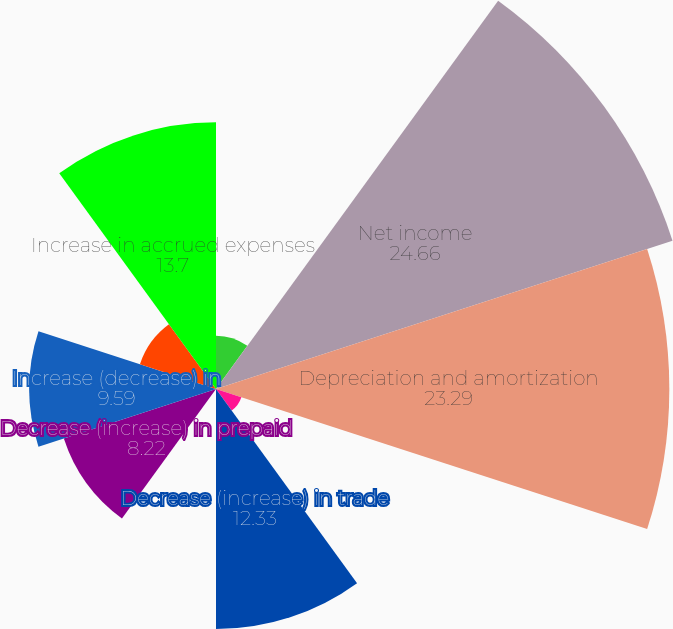Convert chart to OTSL. <chart><loc_0><loc_0><loc_500><loc_500><pie_chart><fcel>(in thousands) Year Ended<fcel>Net income<fcel>Depreciation and amortization<fcel>Accretion of original issue<fcel>Decrease (increase) in trade<fcel>Increase in inventories<fcel>Decrease (increase) in prepaid<fcel>Increase (decrease) in<fcel>(Decrease) increase in accrued<fcel>Increase in accrued expenses<nl><fcel>2.74%<fcel>24.66%<fcel>23.29%<fcel>1.37%<fcel>12.33%<fcel>0.0%<fcel>8.22%<fcel>9.59%<fcel>4.11%<fcel>13.7%<nl></chart> 